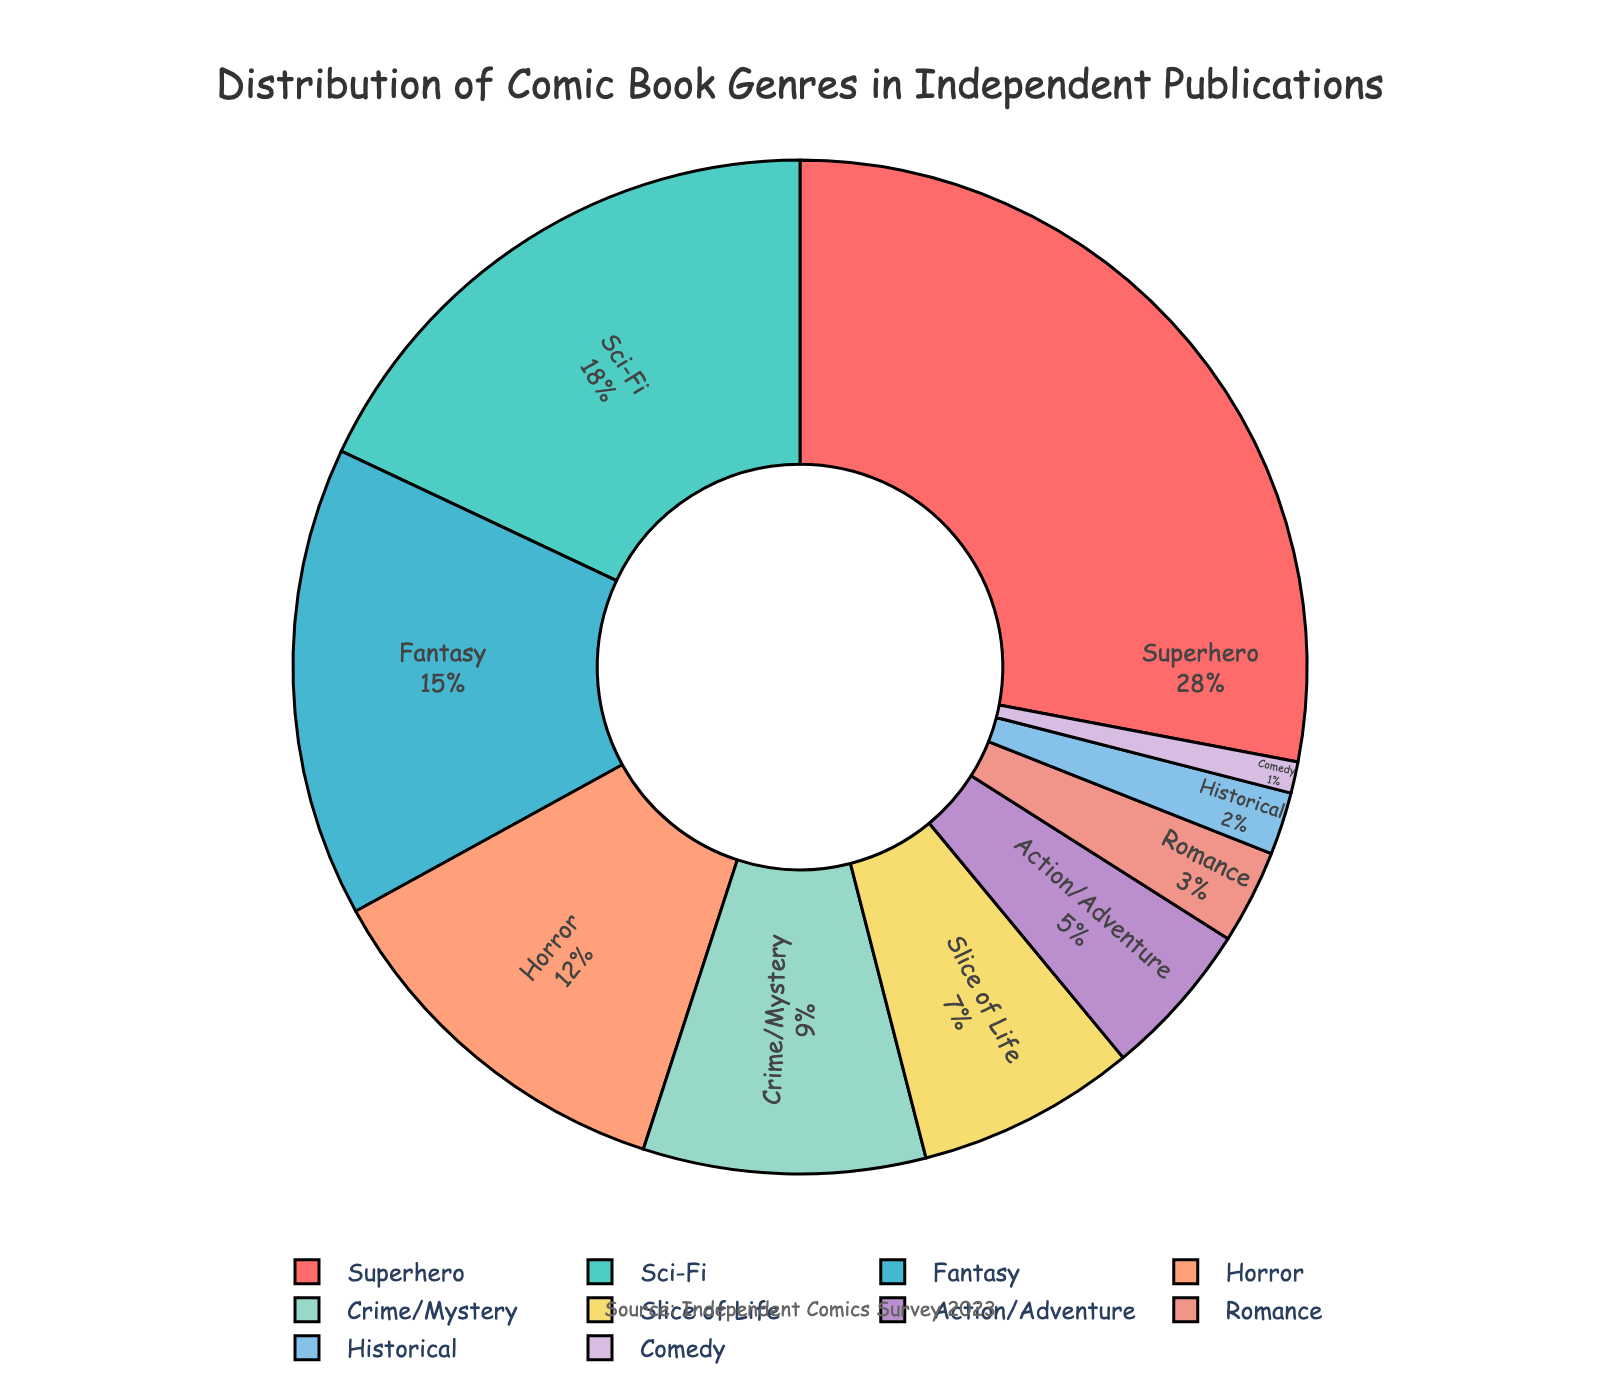What genre has the highest percentage of independent comic book publications? The genre with the highest percentage will appear largest in the pie chart and have the highest numerical value next to it. In our case, "Superhero" has the largest section with 28%.
Answer: Superhero Which two genres together make up over one-third of independent comic book publications? By adding the percentages of the top two genres (Superhero: 28% and Sci-Fi: 18%), we get 28 + 18 = 46%, which is greater than one-third (33.33%).
Answer: Superhero and Sci-Fi What is the combined percentage of Slice of Life, Romance, Historical, and Comedy genres in independent comic book publications? Summing up the percentages for the given genres: Slice of Life (7%) + Romance (3%) + Historical (2%) + Comedy (1%) = 13%.
Answer: 13% How does the percentage of Fantasy compare to Horror in independent comic book publications? Look at the two sections for Fantasy and Horror. Fantasy has 15% and Horror has 12%. Fantasy is larger by 3%.
Answer: Fantasy is 3% larger What percentage of independent comic book publications are in genres with less than 5% representation each? The genres with less than 5% are Action/Adventure (5%), Romance (3%), Historical (2%), and Comedy (1%). Summing these gives 5 + 3 + 2 + 1 = 11%.
Answer: 11% Which genre has the smallest representation in independent comic book publications, and what is its percentage? The smallest piece of the pie chart represents the genre with the lowest percentage. Comedy is the smallest with 1%.
Answer: Comedy, 1% What is the difference in percentage between Sci-Fi and Crime/Mystery genres? Sci-Fi has 18% and Crime/Mystery has 9%. The difference is 18 - 9 = 9%.
Answer: 9% How much larger is the Superhero genre compared to the Action/Adventure genre in terms of percentage? Superhero has 28% and Action/Adventure has 5%. The difference is 28 - 5 = 23%.
Answer: 23% What is the average percentage of the top three most popular genres? The top three are Superhero (28%), Sci-Fi (18%), and Fantasy (15%). The sum is 28 + 18 + 15 = 61. The average is 61 / 3 = 20.33%.
Answer: 20.33% What color represents the Horror genre in the pie chart? By looking at the visual attributes in the pie chart, the Horror genre is marked with a section that is colored in #FFA07A. In words, this color can be described as a shade of light orange.
Answer: Light orange 